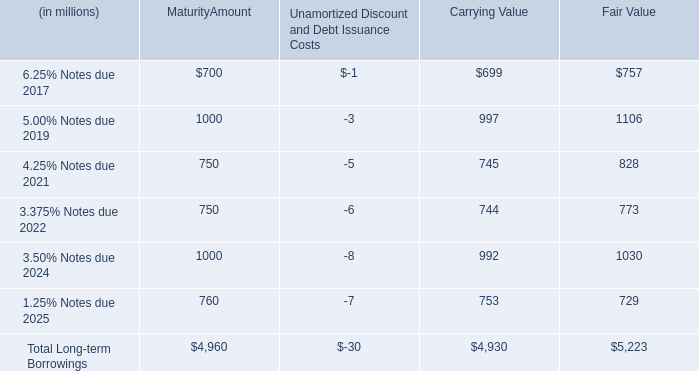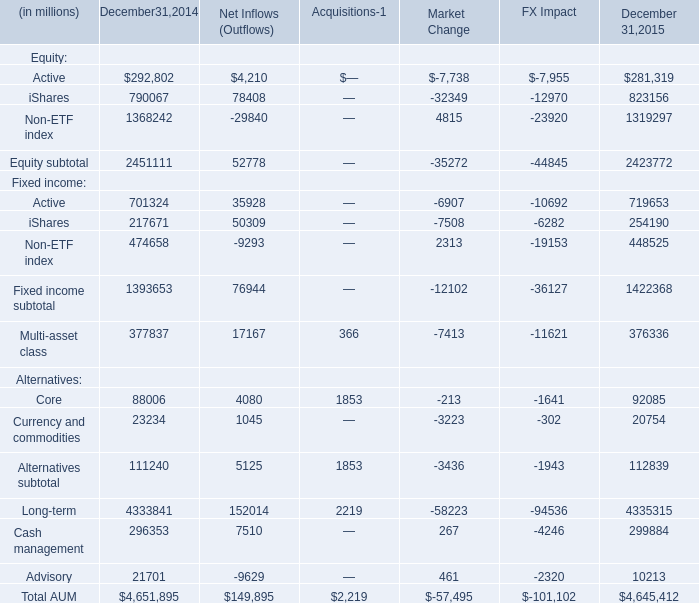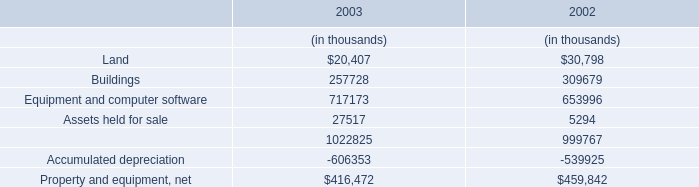how much will the company pay in interest on the 2022 notes between 2012 and 2022 ? in millions $ . 
Computations: ((25 / 2) * ((10 * 2) + 1))
Answer: 262.5. If iShares develops with the same growth rate in 2015, what will it reach in 2016? (in millions) 
Computations: ((1 + ((823156 - 790067) / 790067)) * 823156)
Answer: 857630.80895. 